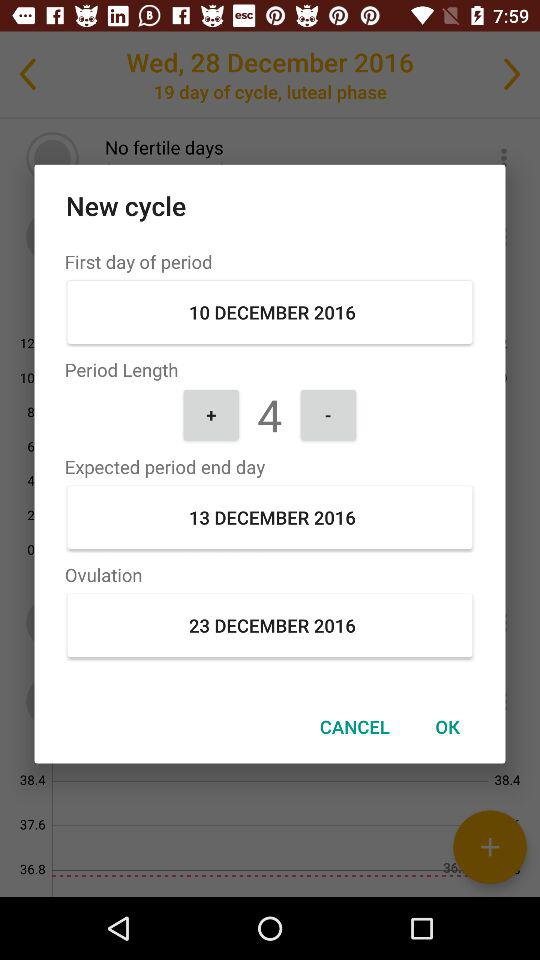What is the date of the first day of the period? The date is December 10, 2016. 